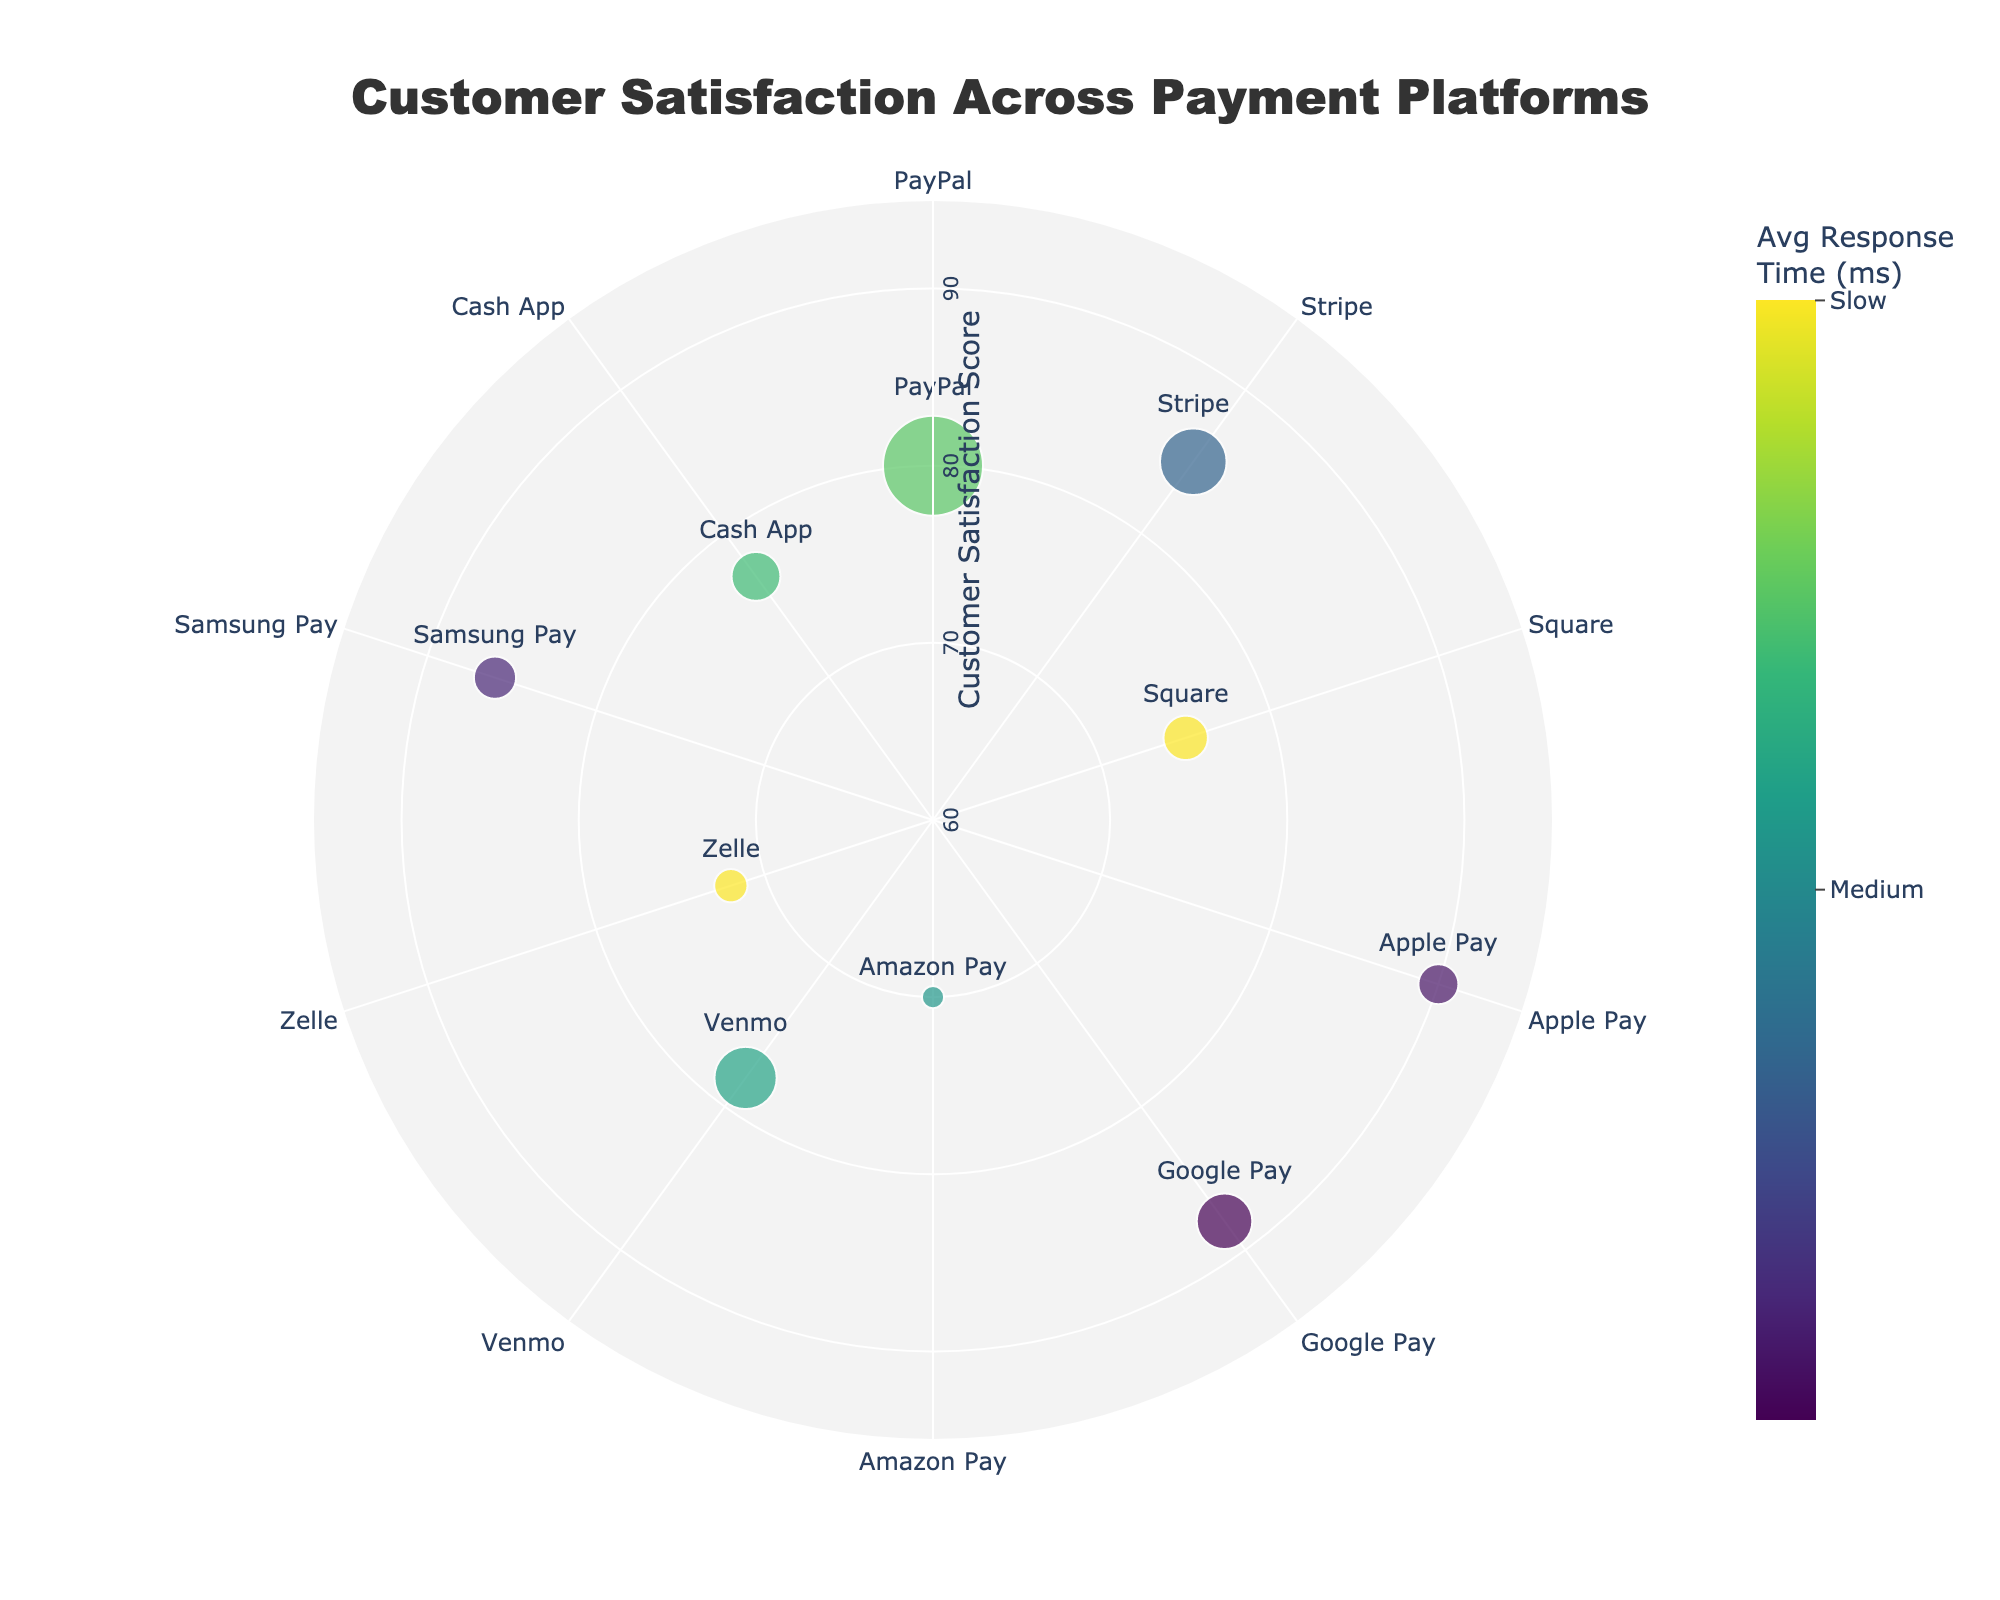What is the title of the chart? The title of the chart is usually located at the top center of the figure. In this case, it is written in bold, large font and color, indicating the main focus of the visualization.
Answer: Customer Satisfaction Across Payment Platforms Which platform has the highest customer satisfaction score? To identify the highest customer satisfaction score, look for the radial axis label associated with the highest point on the plot.
Answer: Apple Pay How does the Average Response Time (ms) affect the marker color in the chart? The marker color is determined by the Average Response Time (ms), with a color scale ranging from green (fast) to purple (slow), as indicated by the colorscale legend.
Answer: Faster response times are shown in greenish colors, while slower response times are shown in purplish colors Which platform has the most number of reviews and what is its satisfaction score? The size of the markers indicates the number of reviews. Locate the largest marker and check its corresponding platform and satisfaction score.
Answer: PayPal, 80 How many platforms have a satisfaction score greater than 85? To answer this, count the number of platforms with markers placed on radial positions beyond 85 on the satisfaction score axis.
Answer: 3 What is the relationship between Square and Zelle in terms of satisfaction score and average response time? Compare the radial positions of Square and Zelle for satisfaction scores and observe the marker colors for average response times.
Answer: Square has a score of 75 and a slower response time; Zelle has a score of 72 and an equally slow response time Which platform combines higher customer satisfaction and faster average response time? Look for platforms located further out on the radial axis (high satisfaction) while having greenish marker colors (fast response).
Answer: Apple Pay Is there a correlation between the number of reviews and customer satisfaction scores among the platforms? Observe if larger markers (more reviews) are consistently located further out on the radial axis (higher satisfaction), or if there isn't a clear pattern.
Answer: No clear correlation Which platform has the lowest customer satisfaction score and what is its average response time? Find the platform with the lowest point on the radial axis and check its tooltip for average response time.
Answer: Amazon Pay, 310 ms Compare the customer satisfaction scores between Venmo and Cash App. Which one is higher and by how much? Locate the markers for Venmo and Cash App on the radial axis, note their scores, and compute the difference.
Answer: Venmo is higher by 1 point (78 vs. 77) 